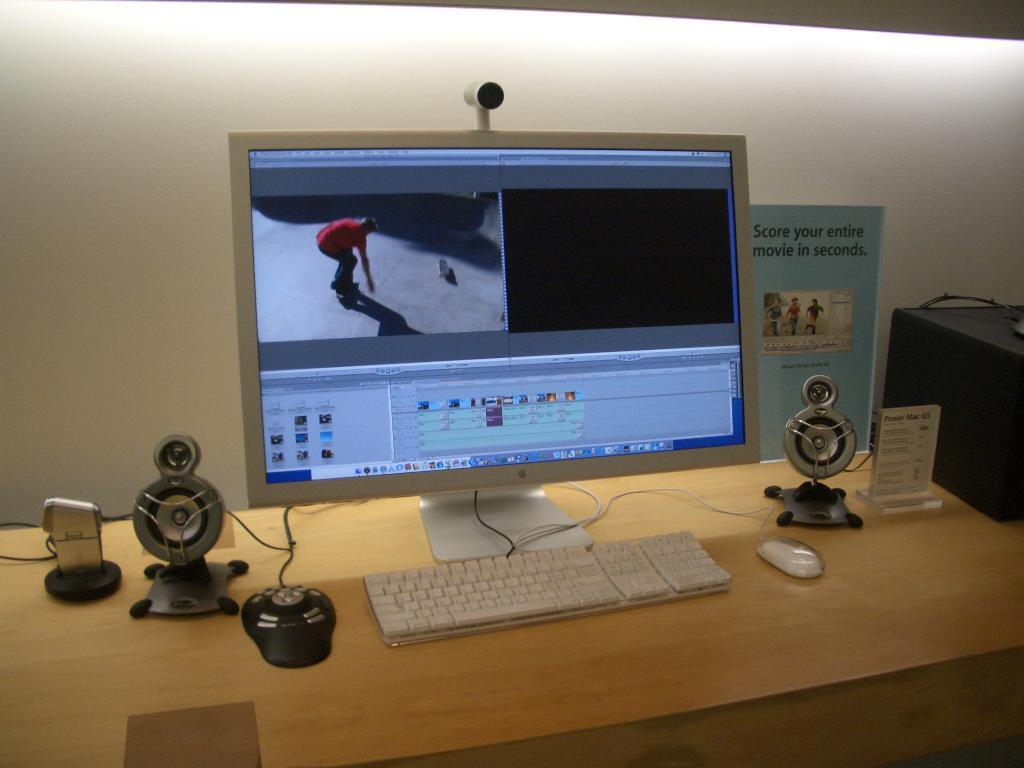<image>
Write a terse but informative summary of the picture. A desk with a Mac computer monitor and a flyer that says Score your entire movie in seconds. 